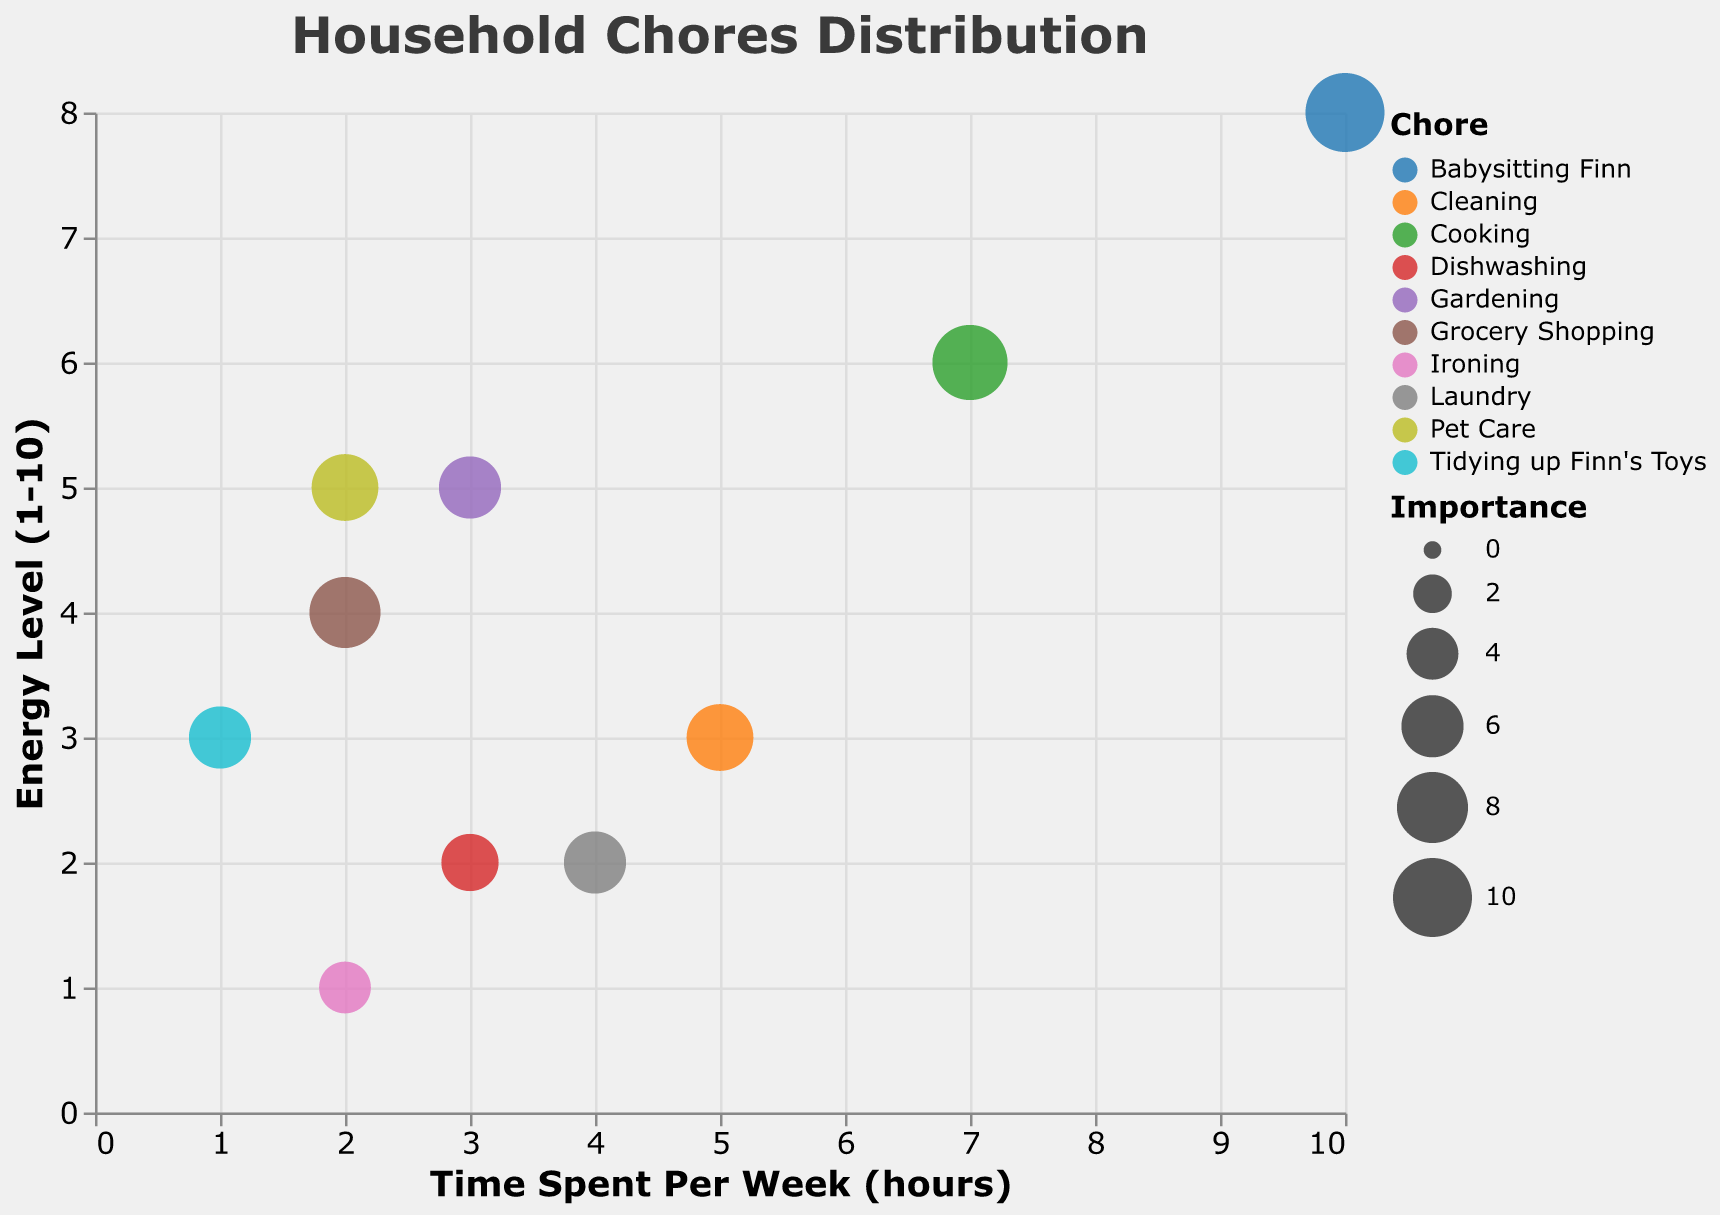What is the title of the bubble chart? The title is visible at the top of the chart. By looking there, we can see the text indicating the title.
Answer: Household Chores Distribution Which chore requires the maximum time spent per week? By looking at the x-axis and identifying the point farthest to the right, we see the chore "Babysitting Finn" demands the most time.
Answer: Babysitting Finn Which chore has the highest energy level? By scanning the y-axis and noting the point highest on the chart, "Babysitting Finn" has the highest energy level.
Answer: Babysitting Finn Which chore has the greatest importance? The size of the bubbles represents importance. The largest bubble visually represents "Babysitting Finn."
Answer: Babysitting Finn What chore requires the least energy and how much energy does it require? By observing the lowest point on the y-axis, "Ironing" is the chore with the least energy, which is 1.
Answer: Ironing, 1 Which chore is the least important and how can you tell? The smallest bubble on the chart belongs to "Ironing," indicating its low level of importance.
Answer: Ironing Compare the chores "Cooking" and "Laundry" in terms of energy level. Which one requires more energy? By comparing the y-axis positions for both chores, we see "Cooking" has an energy level of 6, and "Laundry" has 2. Thus, "Cooking" requires more energy.
Answer: Cooking Which chore requires more time: "Cleaning" or "Gardening"? By comparing the x-axis positions, "Cleaning" is at 5 hours, while "Gardening" is at 3 hours. So "Cleaning" requires more time.
Answer: Cleaning Which chore is more important: "Grocery Shopping" or "Laundry"? By observing the relative sizes of the bubbles, "Grocery Shopping" is larger, indicating higher importance.
Answer: Grocery Shopping What are the average time spent per week and energy level for "Cooking", "Cleaning", and "Grocery Shopping"? For "Cooking": Time = 7, Energy = 6. For "Cleaning": Time = 5, Energy = 3. For "Grocery Shopping": Time = 2, Energy = 4. Average Time = (7+5+2)/3 = 4.67 hours. Average Energy = (6+3+4)/3 = 4.33.
Answer: 4.67 hours, 4.33 